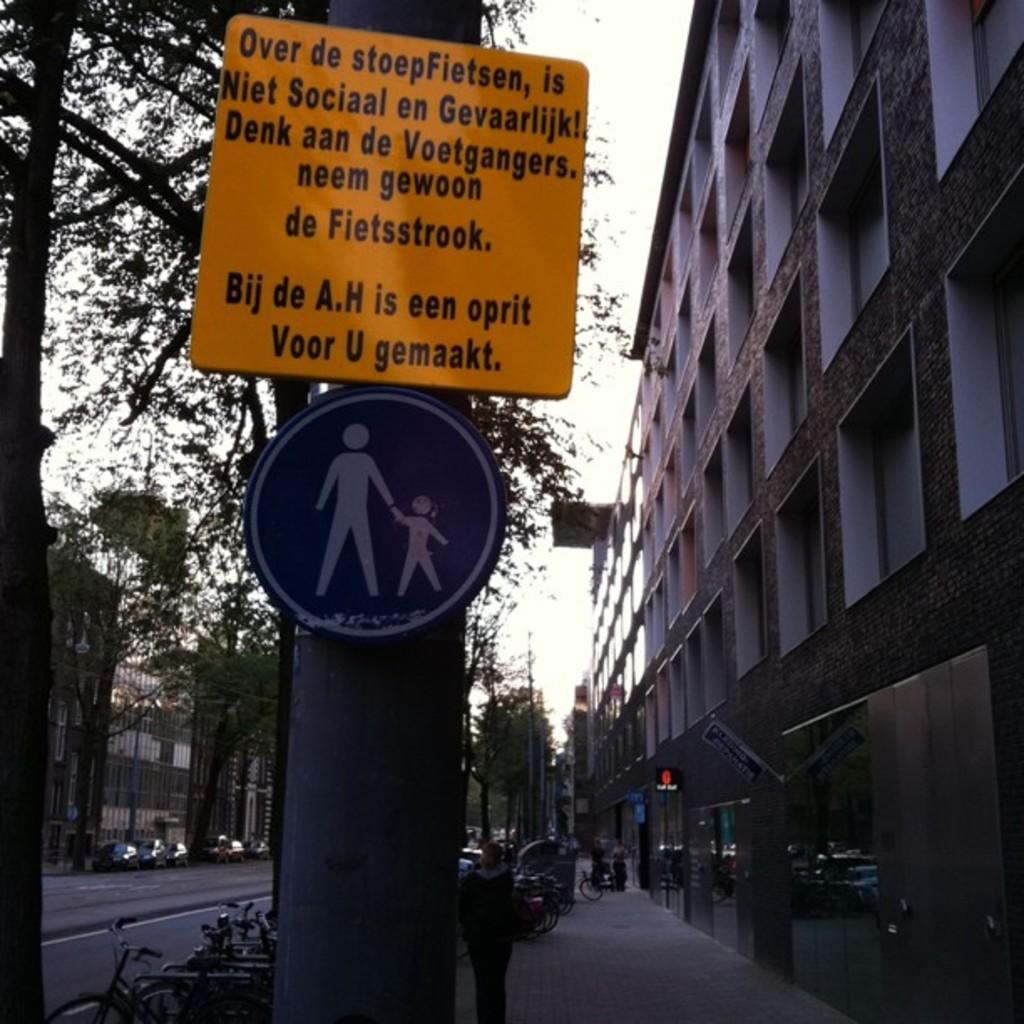<image>
Create a compact narrative representing the image presented. The orange sign is in a foreign language but it warns, "is Niet Sociaal en Gevaarlijk!" 